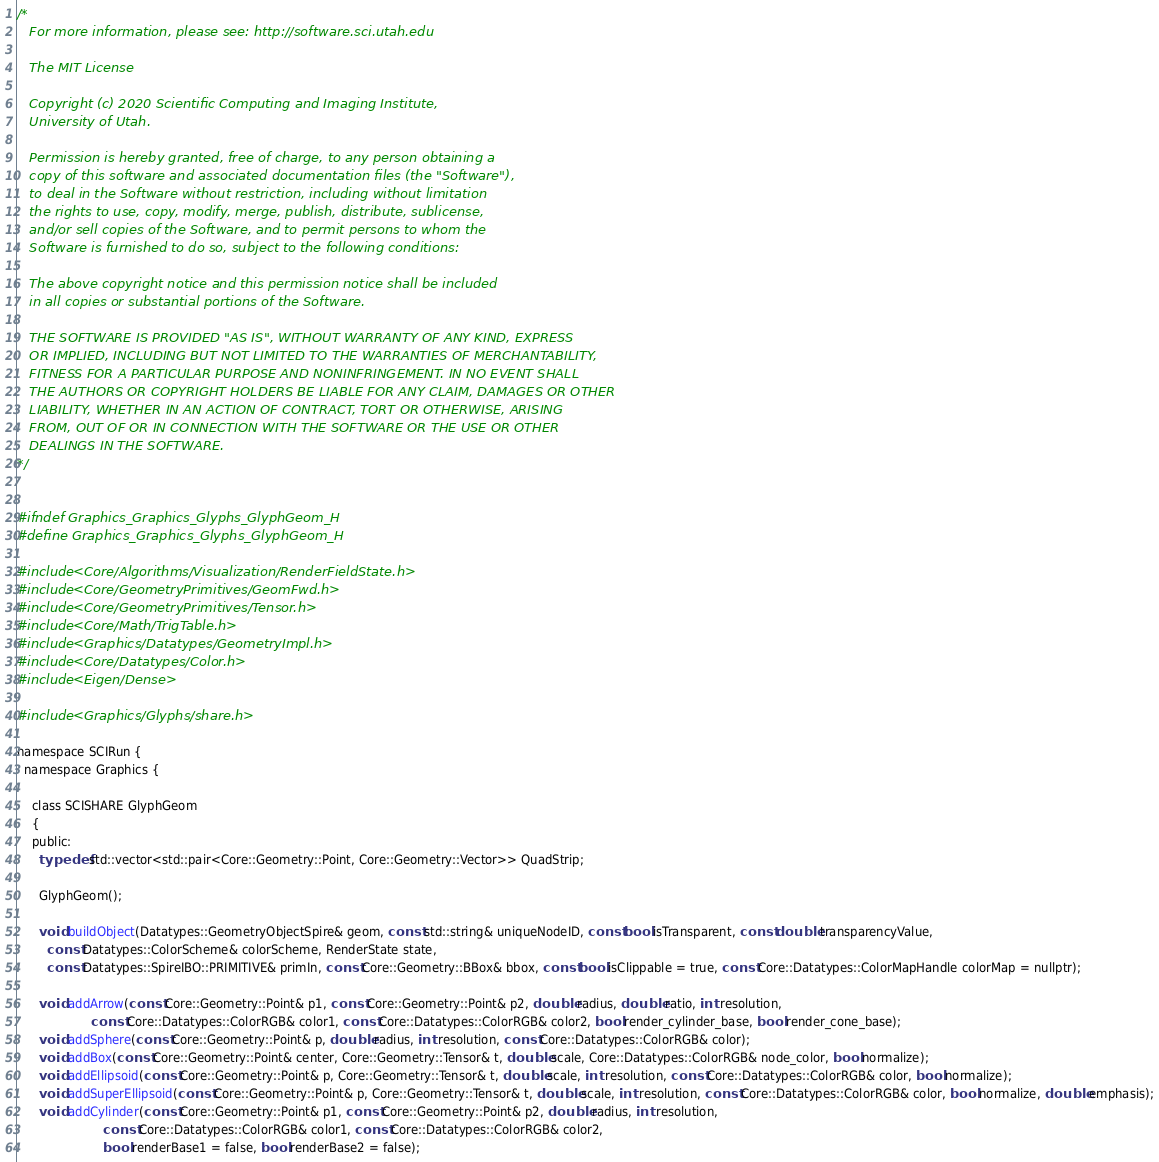<code> <loc_0><loc_0><loc_500><loc_500><_C_>/*
   For more information, please see: http://software.sci.utah.edu

   The MIT License

   Copyright (c) 2020 Scientific Computing and Imaging Institute,
   University of Utah.

   Permission is hereby granted, free of charge, to any person obtaining a
   copy of this software and associated documentation files (the "Software"),
   to deal in the Software without restriction, including without limitation
   the rights to use, copy, modify, merge, publish, distribute, sublicense,
   and/or sell copies of the Software, and to permit persons to whom the
   Software is furnished to do so, subject to the following conditions:

   The above copyright notice and this permission notice shall be included
   in all copies or substantial portions of the Software.

   THE SOFTWARE IS PROVIDED "AS IS", WITHOUT WARRANTY OF ANY KIND, EXPRESS
   OR IMPLIED, INCLUDING BUT NOT LIMITED TO THE WARRANTIES OF MERCHANTABILITY,
   FITNESS FOR A PARTICULAR PURPOSE AND NONINFRINGEMENT. IN NO EVENT SHALL
   THE AUTHORS OR COPYRIGHT HOLDERS BE LIABLE FOR ANY CLAIM, DAMAGES OR OTHER
   LIABILITY, WHETHER IN AN ACTION OF CONTRACT, TORT OR OTHERWISE, ARISING
   FROM, OUT OF OR IN CONNECTION WITH THE SOFTWARE OR THE USE OR OTHER
   DEALINGS IN THE SOFTWARE.
*/


#ifndef Graphics_Graphics_Glyphs_GlyphGeom_H
#define Graphics_Graphics_Glyphs_GlyphGeom_H

#include <Core/Algorithms/Visualization/RenderFieldState.h>
#include <Core/GeometryPrimitives/GeomFwd.h>
#include <Core/GeometryPrimitives/Tensor.h>
#include <Core/Math/TrigTable.h>
#include <Graphics/Datatypes/GeometryImpl.h>
#include <Core/Datatypes/Color.h>
#include <Eigen/Dense>

#include <Graphics/Glyphs/share.h>

namespace SCIRun {
  namespace Graphics {

    class SCISHARE GlyphGeom
    {
    public:
      typedef std::vector<std::pair<Core::Geometry::Point, Core::Geometry::Vector>> QuadStrip;

      GlyphGeom();

      void buildObject(Datatypes::GeometryObjectSpire& geom, const std::string& uniqueNodeID, const bool isTransparent, const double transparencyValue,
        const Datatypes::ColorScheme& colorScheme, RenderState state,
        const Datatypes::SpireIBO::PRIMITIVE& primIn, const Core::Geometry::BBox& bbox, const bool isClippable = true, const Core::Datatypes::ColorMapHandle colorMap = nullptr);

      void addArrow(const Core::Geometry::Point& p1, const Core::Geometry::Point& p2, double radius, double ratio, int resolution,
                    const Core::Datatypes::ColorRGB& color1, const Core::Datatypes::ColorRGB& color2, bool render_cylinder_base, bool render_cone_base);
      void addSphere(const Core::Geometry::Point& p, double radius, int resolution, const Core::Datatypes::ColorRGB& color);
      void addBox(const Core::Geometry::Point& center, Core::Geometry::Tensor& t, double scale, Core::Datatypes::ColorRGB& node_color, bool normalize);
      void addEllipsoid(const Core::Geometry::Point& p, Core::Geometry::Tensor& t, double scale, int resolution, const Core::Datatypes::ColorRGB& color, bool normalize);
      void addSuperEllipsoid(const Core::Geometry::Point& p, Core::Geometry::Tensor& t, double scale, int resolution, const Core::Datatypes::ColorRGB& color, bool normalize, double emphasis);
      void addCylinder(const Core::Geometry::Point& p1, const Core::Geometry::Point& p2, double radius, int resolution,
                       const Core::Datatypes::ColorRGB& color1, const Core::Datatypes::ColorRGB& color2,
                       bool renderBase1 = false, bool renderBase2 = false);</code> 